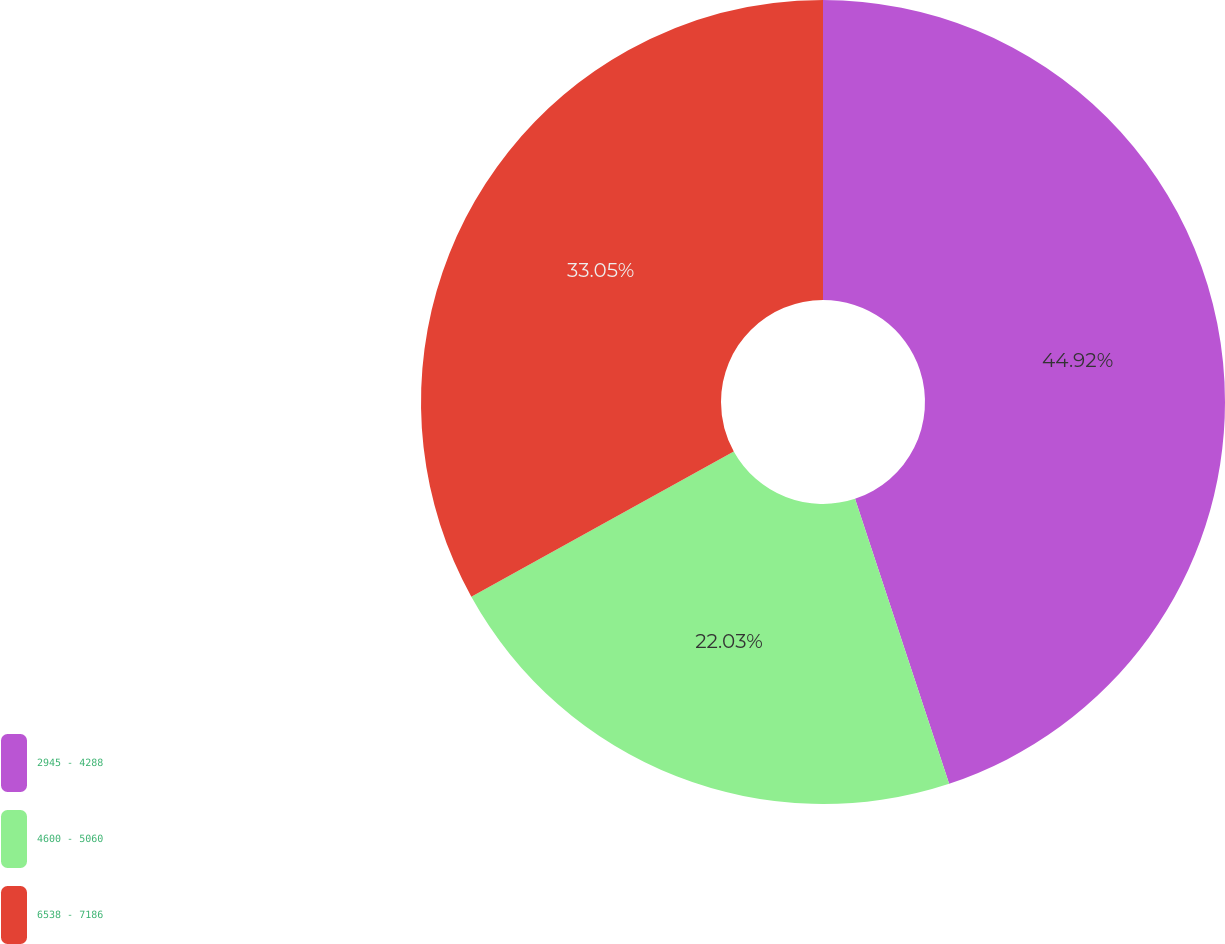<chart> <loc_0><loc_0><loc_500><loc_500><pie_chart><fcel>2945 - 4288<fcel>4600 - 5060<fcel>6538 - 7186<nl><fcel>44.92%<fcel>22.03%<fcel>33.05%<nl></chart> 